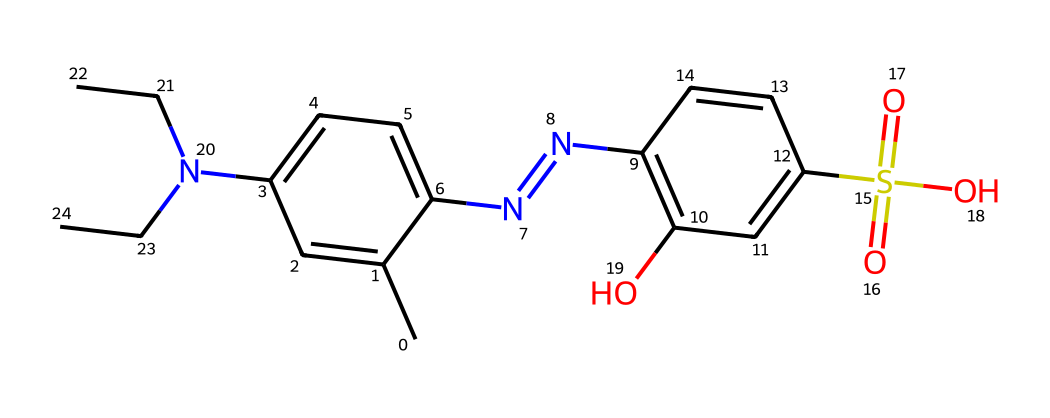What is the total number of carbon atoms in this structure? By examining the structure, we can count the carbon atoms represented in the SMILES notation, which indicates that every 'C' stands for a carbon atom. In this case, there are 15 'C' atoms present in the structure upon counting.
Answer: 15 How many nitrogen atoms are present in this dye? The SMILES notation includes 'N' to denote nitrogen atoms. Counting the occurrences of 'N' in the structure shows that there are 3 nitrogen atoms.
Answer: 3 What type of functional group is represented by "S(=O)(=O)O"? This fragment indicates a sulfonic acid group, where sulfur is bonded to three oxygen atoms, with two of them forming double bonds (the =O) and one that is part of a hydroxyl group (the -OH), characteristic of sulfonic acids.
Answer: sulfonic acid How many double bonds does this structure contain? In the chemical structure, double bonds are represented by '=' symbols. Counting them, we see that there are 4 double bonds present throughout the entire structure.
Answer: 4 What is the role of the hydroxyl group (-OH) in this dye? The hydroxyl group contributes to the dye's solubility in water and can also enhance the bonding of the dye to the fabric by forming hydrogen bonds, which is critical in protective clothing for durability and effectiveness.
Answer: solubility Which part of this structure contributes to its color? The presence of conjugated double bonds within the aromatic rings typically accounts for the chromophores that absorb specific wavelengths of light, leading to the color of the dye, which can be visually identified in the structure.
Answer: conjugated double bonds 